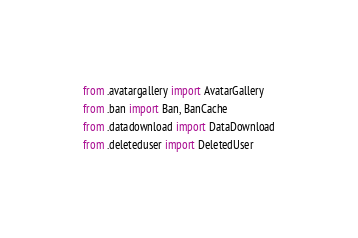<code> <loc_0><loc_0><loc_500><loc_500><_Python_>from .avatargallery import AvatarGallery
from .ban import Ban, BanCache
from .datadownload import DataDownload
from .deleteduser import DeletedUser
</code> 